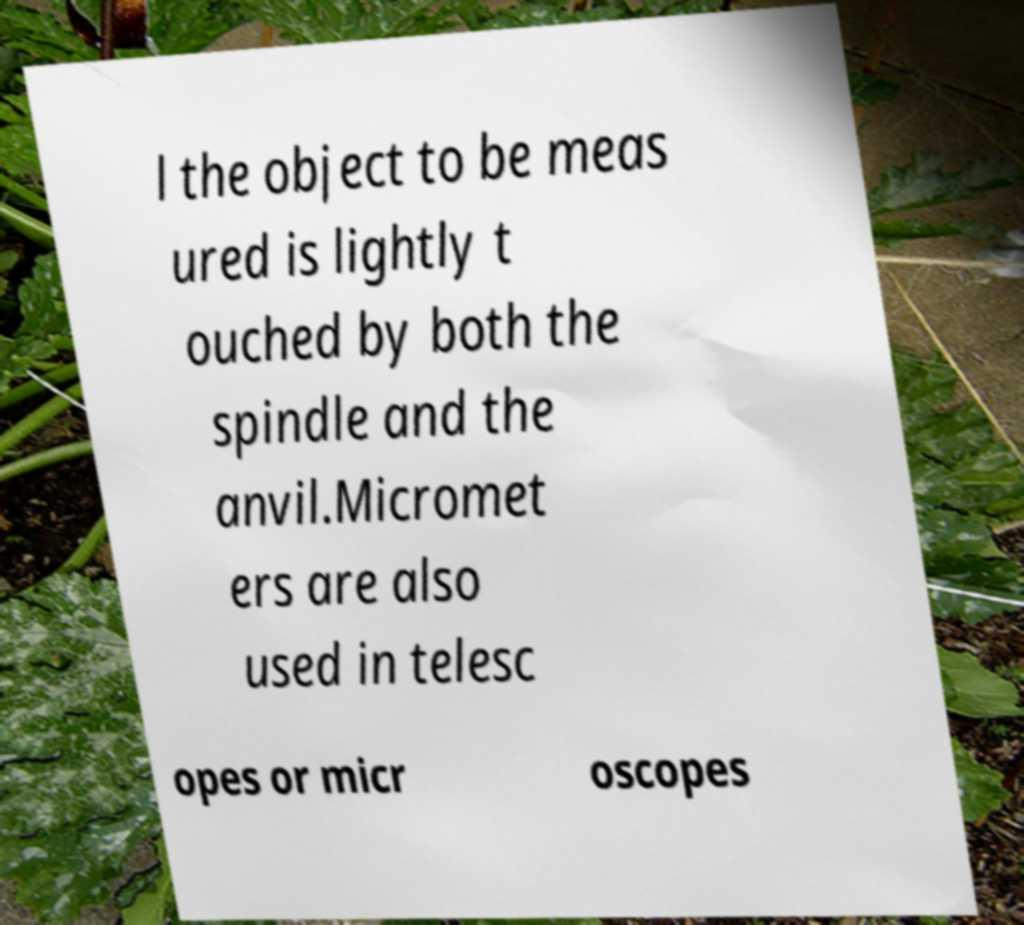There's text embedded in this image that I need extracted. Can you transcribe it verbatim? l the object to be meas ured is lightly t ouched by both the spindle and the anvil.Micromet ers are also used in telesc opes or micr oscopes 